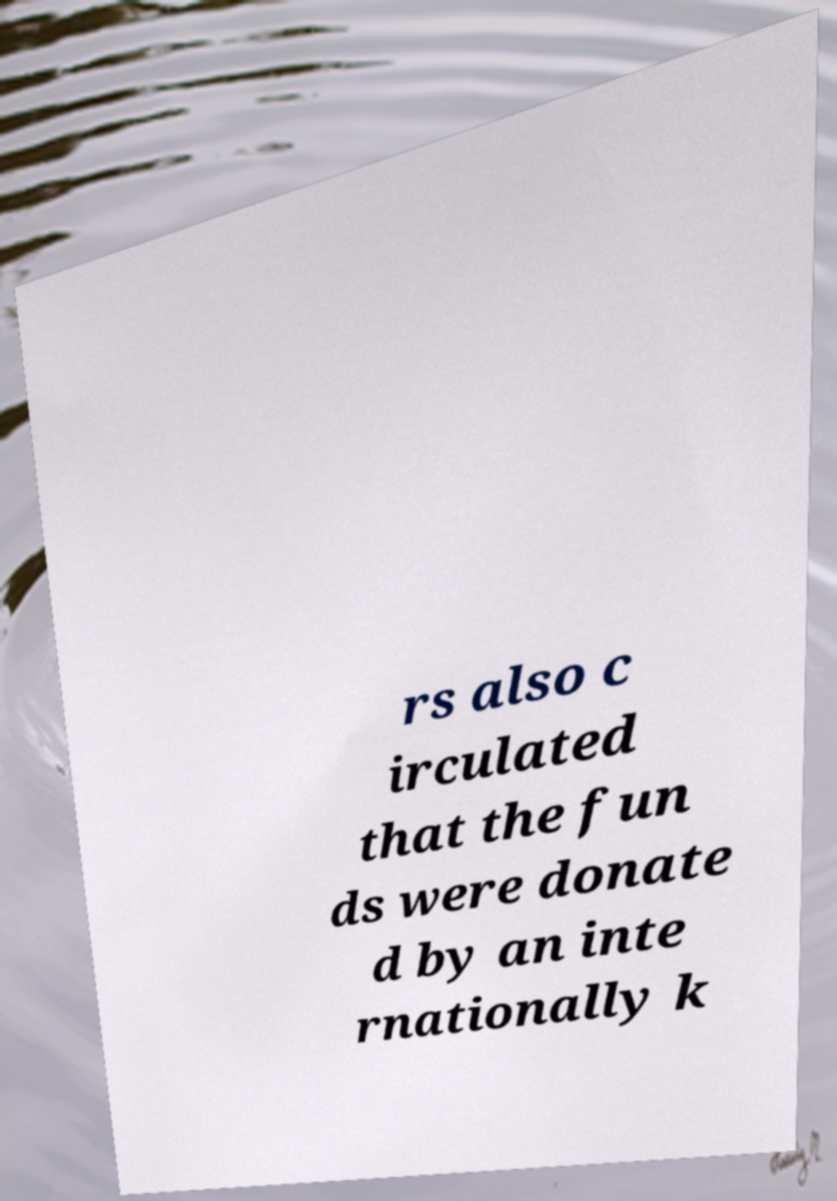For documentation purposes, I need the text within this image transcribed. Could you provide that? rs also c irculated that the fun ds were donate d by an inte rnationally k 